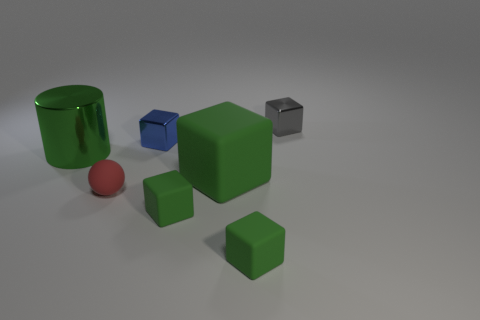Are there an equal number of green matte things that are in front of the tiny sphere and large objects?
Your answer should be very brief. Yes. Is the large thing that is on the right side of the tiny blue shiny block made of the same material as the small object that is left of the small blue metallic cube?
Ensure brevity in your answer.  Yes. How many things are big blocks or tiny matte objects in front of the red matte thing?
Provide a short and direct response. 3. Are there any cyan things of the same shape as the small blue metal object?
Offer a very short reply. No. How big is the metallic cube that is in front of the metal object that is behind the tiny metal thing to the left of the gray cube?
Provide a short and direct response. Small. Is the number of large cylinders that are left of the gray cube the same as the number of tiny balls that are right of the large metallic cylinder?
Keep it short and to the point. Yes. The gray block that is the same material as the big cylinder is what size?
Offer a very short reply. Small. The big matte object is what color?
Provide a short and direct response. Green. What number of tiny objects have the same color as the big cylinder?
Give a very brief answer. 2. There is a blue object that is the same size as the red rubber sphere; what material is it?
Keep it short and to the point. Metal. 